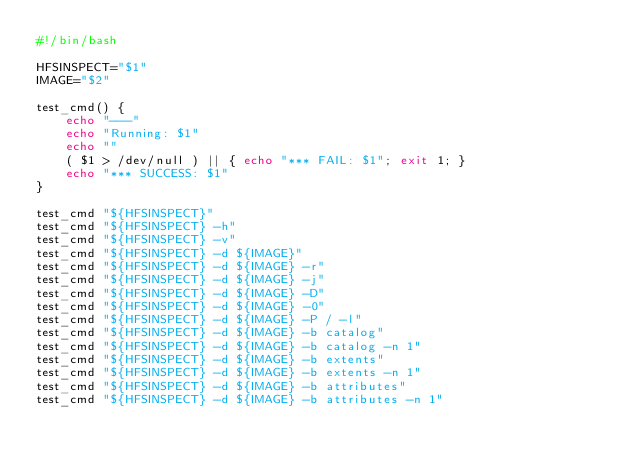Convert code to text. <code><loc_0><loc_0><loc_500><loc_500><_Bash_>#!/bin/bash

HFSINSPECT="$1"
IMAGE="$2"

test_cmd() {
    echo "---"
    echo "Running: $1"
    echo ""
    ( $1 > /dev/null ) || { echo "*** FAIL: $1"; exit 1; }
    echo "*** SUCCESS: $1"
}

test_cmd "${HFSINSPECT}"
test_cmd "${HFSINSPECT} -h"
test_cmd "${HFSINSPECT} -v"
test_cmd "${HFSINSPECT} -d ${IMAGE}"
test_cmd "${HFSINSPECT} -d ${IMAGE} -r"
test_cmd "${HFSINSPECT} -d ${IMAGE} -j"
test_cmd "${HFSINSPECT} -d ${IMAGE} -D"
test_cmd "${HFSINSPECT} -d ${IMAGE} -0"
test_cmd "${HFSINSPECT} -d ${IMAGE} -P / -l"
test_cmd "${HFSINSPECT} -d ${IMAGE} -b catalog"
test_cmd "${HFSINSPECT} -d ${IMAGE} -b catalog -n 1"
test_cmd "${HFSINSPECT} -d ${IMAGE} -b extents"
test_cmd "${HFSINSPECT} -d ${IMAGE} -b extents -n 1"
test_cmd "${HFSINSPECT} -d ${IMAGE} -b attributes"
test_cmd "${HFSINSPECT} -d ${IMAGE} -b attributes -n 1"
</code> 